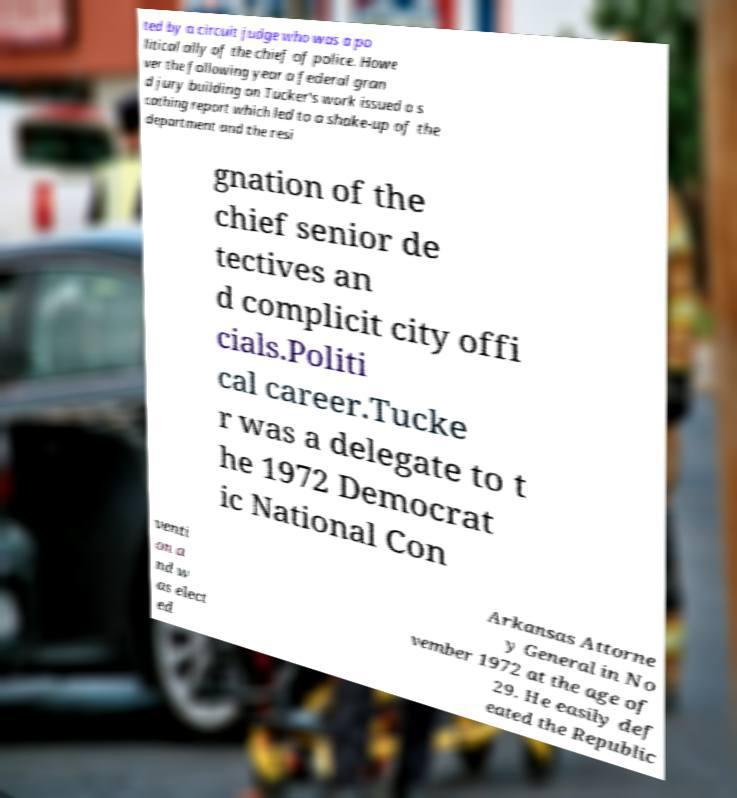Please identify and transcribe the text found in this image. ted by a circuit judge who was a po litical ally of the chief of police. Howe ver the following year a federal gran d jury building on Tucker's work issued a s cathing report which led to a shake-up of the department and the resi gnation of the chief senior de tectives an d complicit city offi cials.Politi cal career.Tucke r was a delegate to t he 1972 Democrat ic National Con venti on a nd w as elect ed Arkansas Attorne y General in No vember 1972 at the age of 29. He easily def eated the Republic 